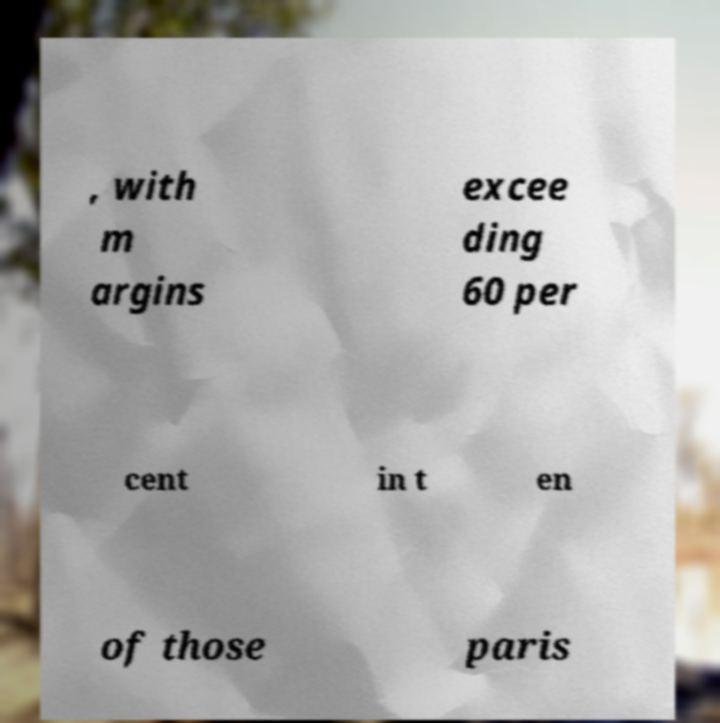Can you accurately transcribe the text from the provided image for me? , with m argins excee ding 60 per cent in t en of those paris 